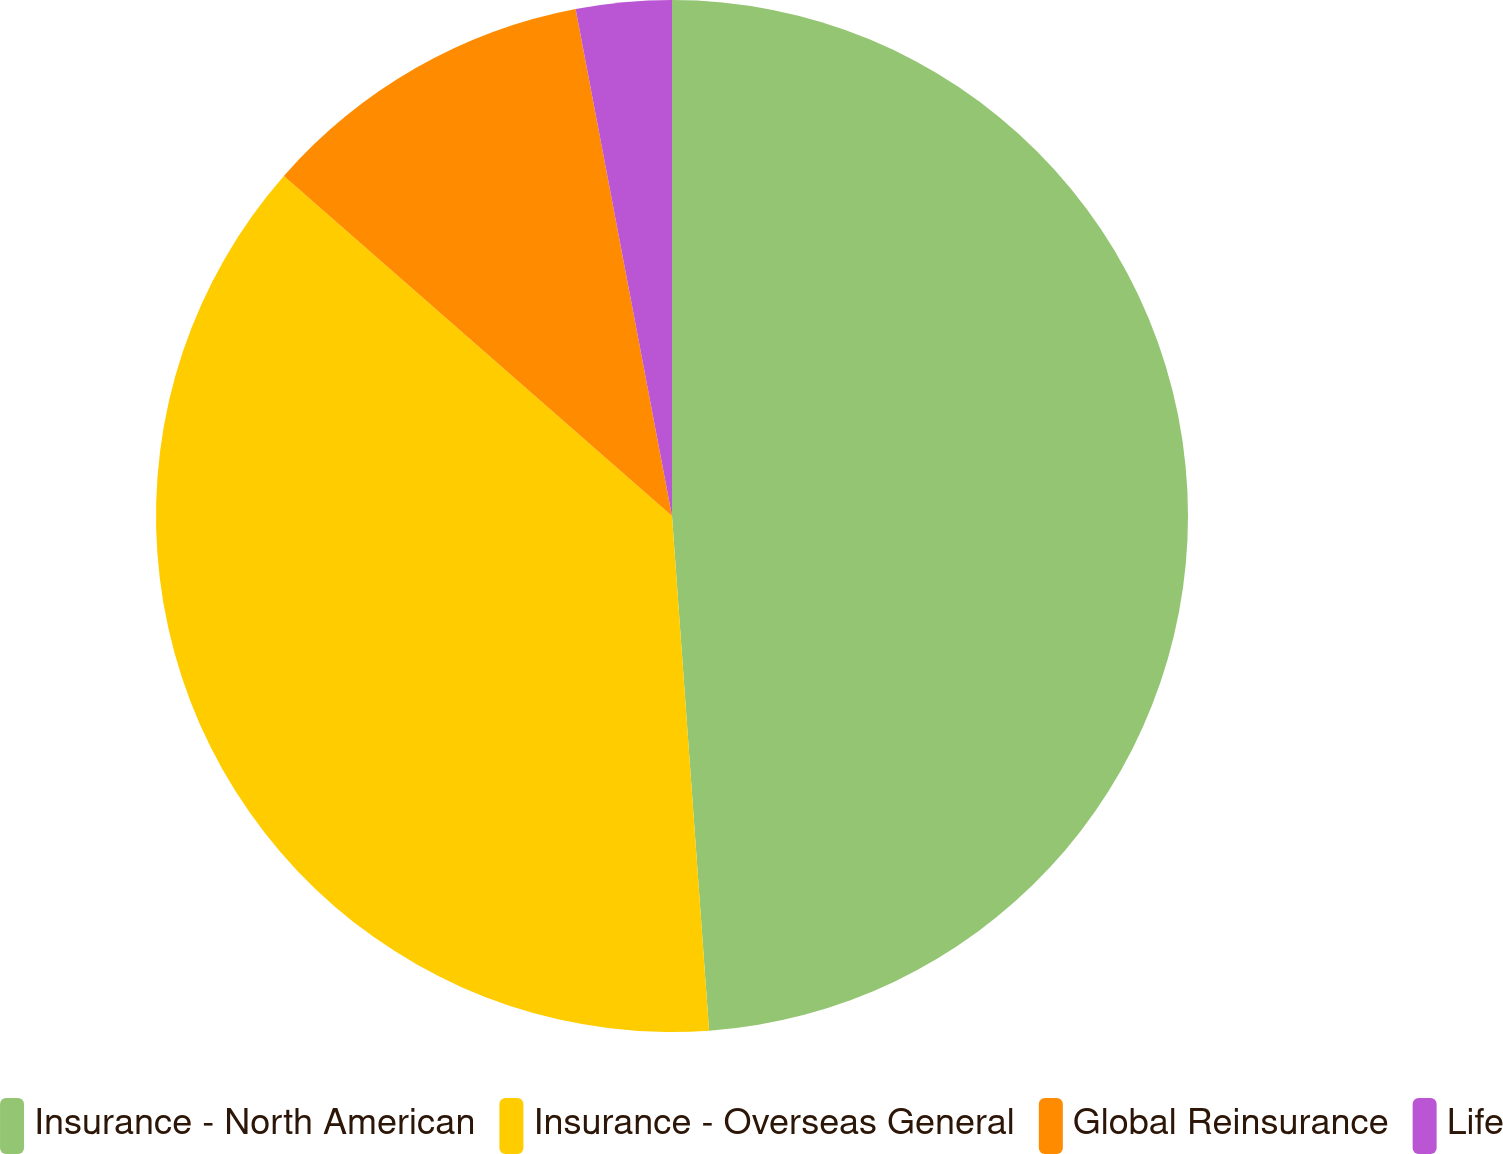Convert chart to OTSL. <chart><loc_0><loc_0><loc_500><loc_500><pie_chart><fcel>Insurance - North American<fcel>Insurance - Overseas General<fcel>Global Reinsurance<fcel>Life<nl><fcel>48.85%<fcel>37.59%<fcel>10.56%<fcel>2.99%<nl></chart> 